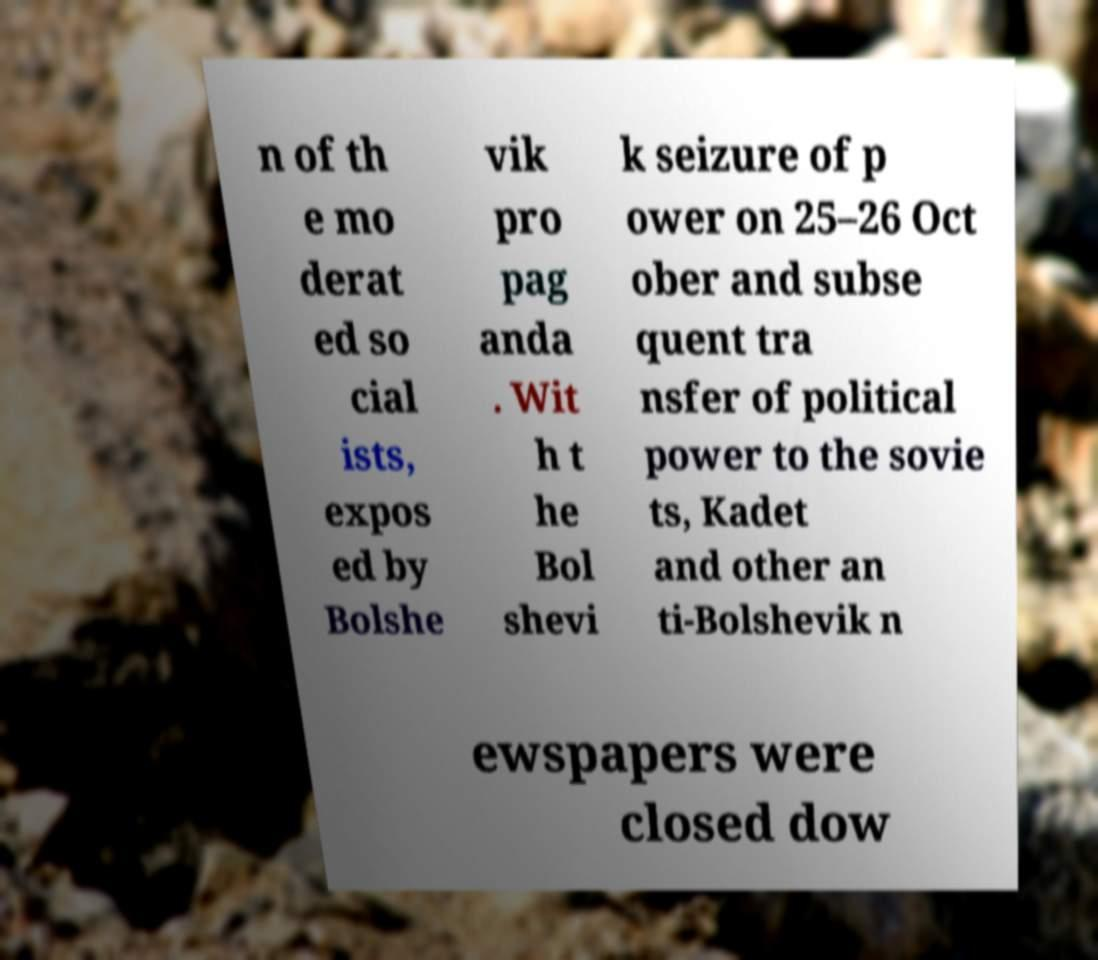Can you accurately transcribe the text from the provided image for me? n of th e mo derat ed so cial ists, expos ed by Bolshe vik pro pag anda . Wit h t he Bol shevi k seizure of p ower on 25–26 Oct ober and subse quent tra nsfer of political power to the sovie ts, Kadet and other an ti-Bolshevik n ewspapers were closed dow 